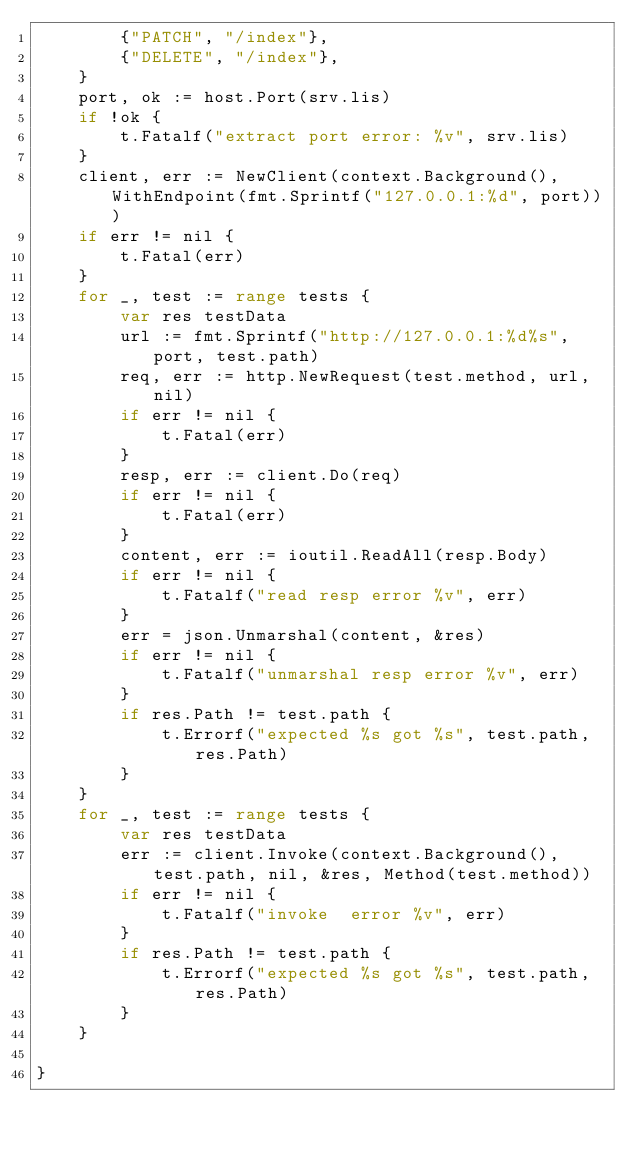Convert code to text. <code><loc_0><loc_0><loc_500><loc_500><_Go_>		{"PATCH", "/index"},
		{"DELETE", "/index"},
	}
	port, ok := host.Port(srv.lis)
	if !ok {
		t.Fatalf("extract port error: %v", srv.lis)
	}
	client, err := NewClient(context.Background(), WithEndpoint(fmt.Sprintf("127.0.0.1:%d", port)))
	if err != nil {
		t.Fatal(err)
	}
	for _, test := range tests {
		var res testData
		url := fmt.Sprintf("http://127.0.0.1:%d%s", port, test.path)
		req, err := http.NewRequest(test.method, url, nil)
		if err != nil {
			t.Fatal(err)
		}
		resp, err := client.Do(req)
		if err != nil {
			t.Fatal(err)
		}
		content, err := ioutil.ReadAll(resp.Body)
		if err != nil {
			t.Fatalf("read resp error %v", err)
		}
		err = json.Unmarshal(content, &res)
		if err != nil {
			t.Fatalf("unmarshal resp error %v", err)
		}
		if res.Path != test.path {
			t.Errorf("expected %s got %s", test.path, res.Path)
		}
	}
	for _, test := range tests {
		var res testData
		err := client.Invoke(context.Background(), test.path, nil, &res, Method(test.method))
		if err != nil {
			t.Fatalf("invoke  error %v", err)
		}
		if res.Path != test.path {
			t.Errorf("expected %s got %s", test.path, res.Path)
		}
	}

}
</code> 